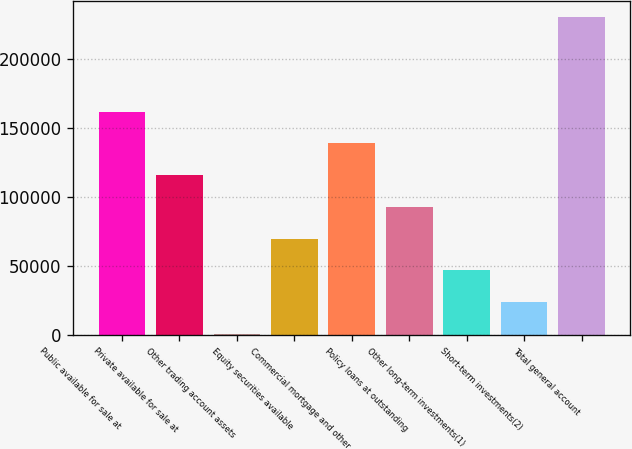<chart> <loc_0><loc_0><loc_500><loc_500><bar_chart><fcel>Public available for sale at<fcel>Private available for sale at<fcel>Other trading account assets<fcel>Equity securities available<fcel>Commercial mortgage and other<fcel>Policy loans at outstanding<fcel>Other long-term investments(1)<fcel>Short-term investments(2)<fcel>Total general account<nl><fcel>161500<fcel>115600<fcel>848<fcel>69698.9<fcel>138550<fcel>92649.2<fcel>46748.6<fcel>23798.3<fcel>230351<nl></chart> 